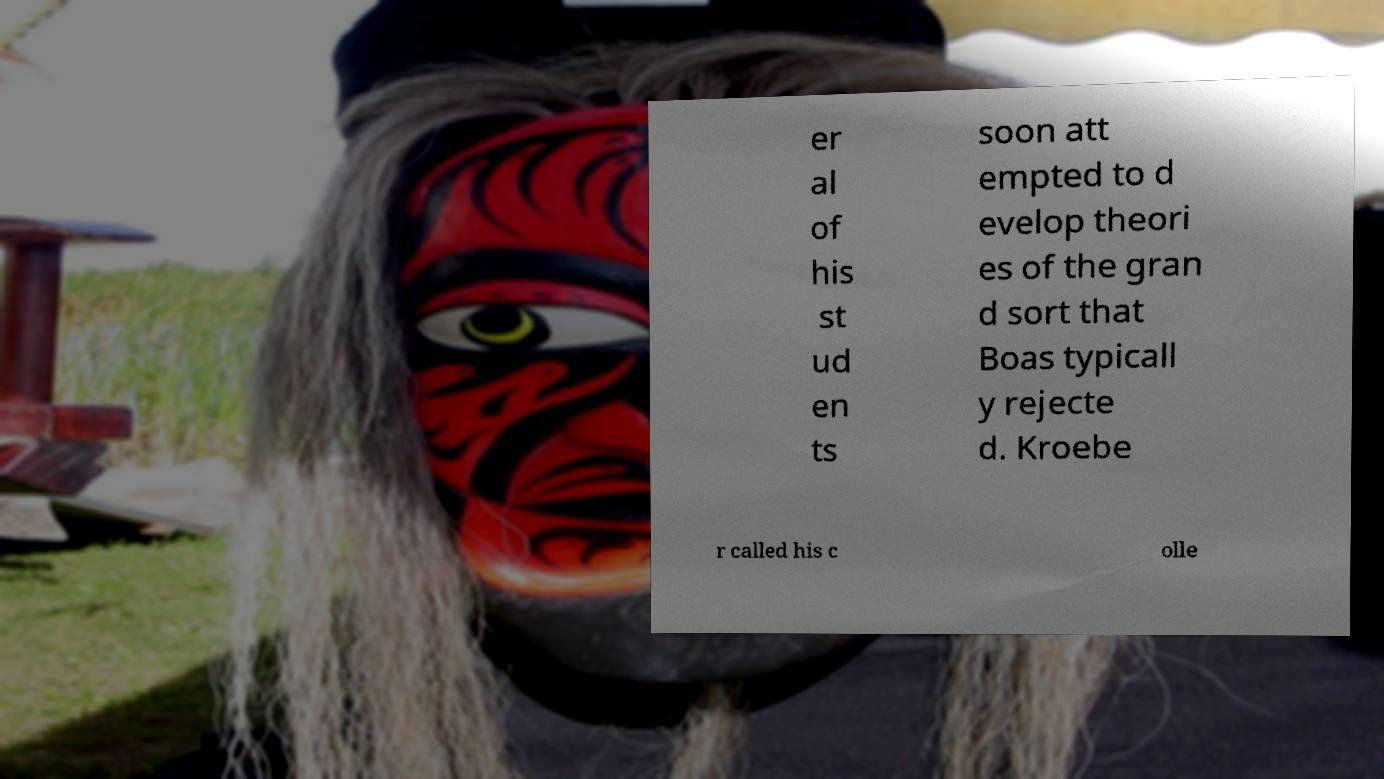Can you accurately transcribe the text from the provided image for me? er al of his st ud en ts soon att empted to d evelop theori es of the gran d sort that Boas typicall y rejecte d. Kroebe r called his c olle 